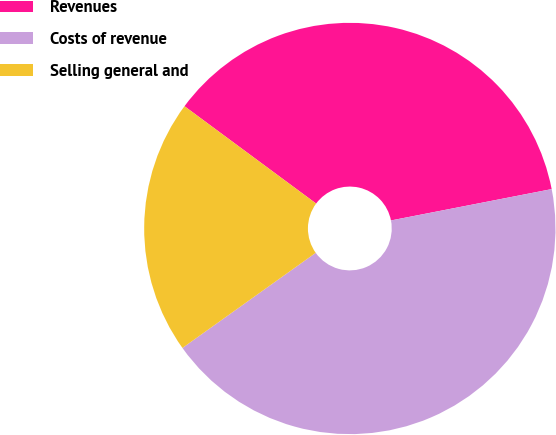<chart> <loc_0><loc_0><loc_500><loc_500><pie_chart><fcel>Revenues<fcel>Costs of revenue<fcel>Selling general and<nl><fcel>36.8%<fcel>43.2%<fcel>20.0%<nl></chart> 